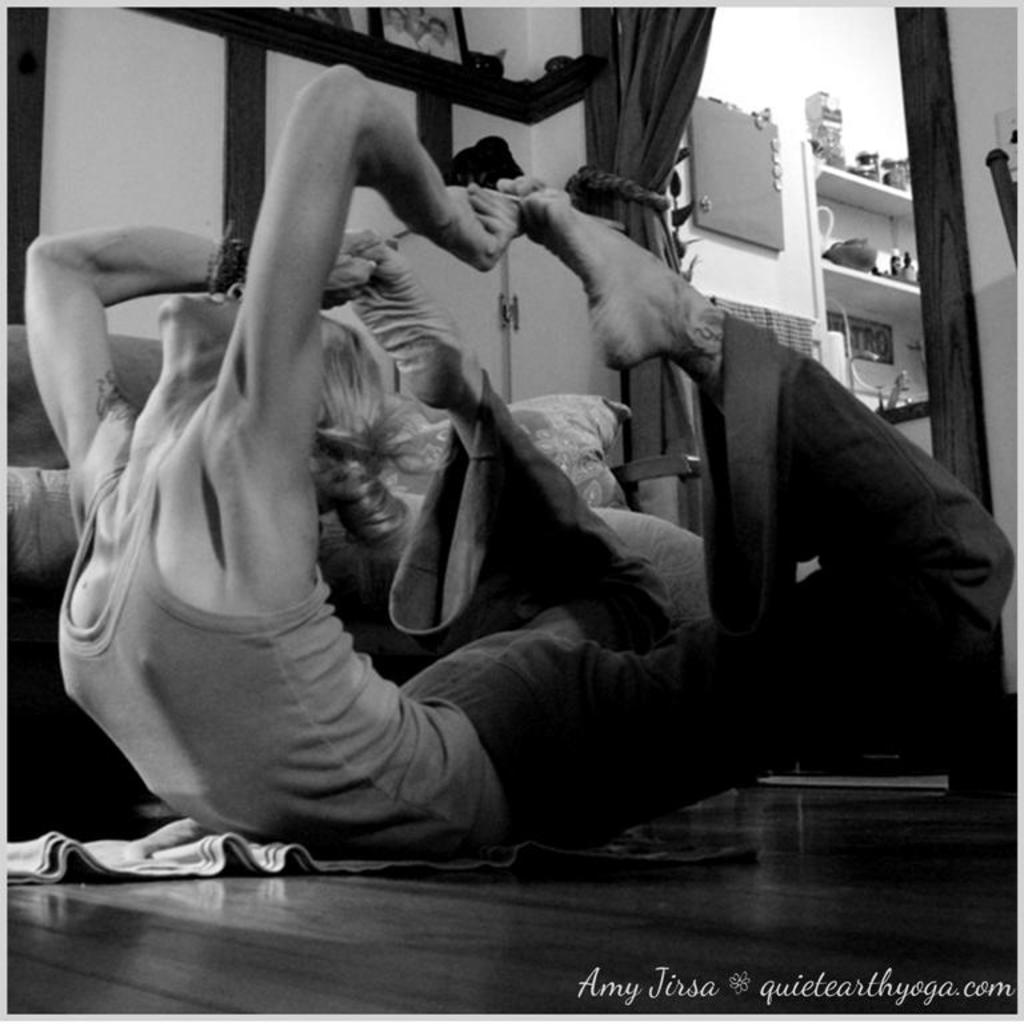What is the person in the image doing? The person in the image is doing exercise. What can be seen in the background of the image? There is a couch in the background of the image, and it has pillows on it. What is on the wall in the image? There are frames on the wall. What type of window treatment is present in the image? There are curtains in the image. What is on the cupboard in the image? There are objects on the cupboard. What is the color scheme of the image? The image is in black and white. What type of nut is being used as a lamp in the image? There is no nut or lamp present in the image; it is a black and white image of a person exercising in a room with various objects and furniture. 